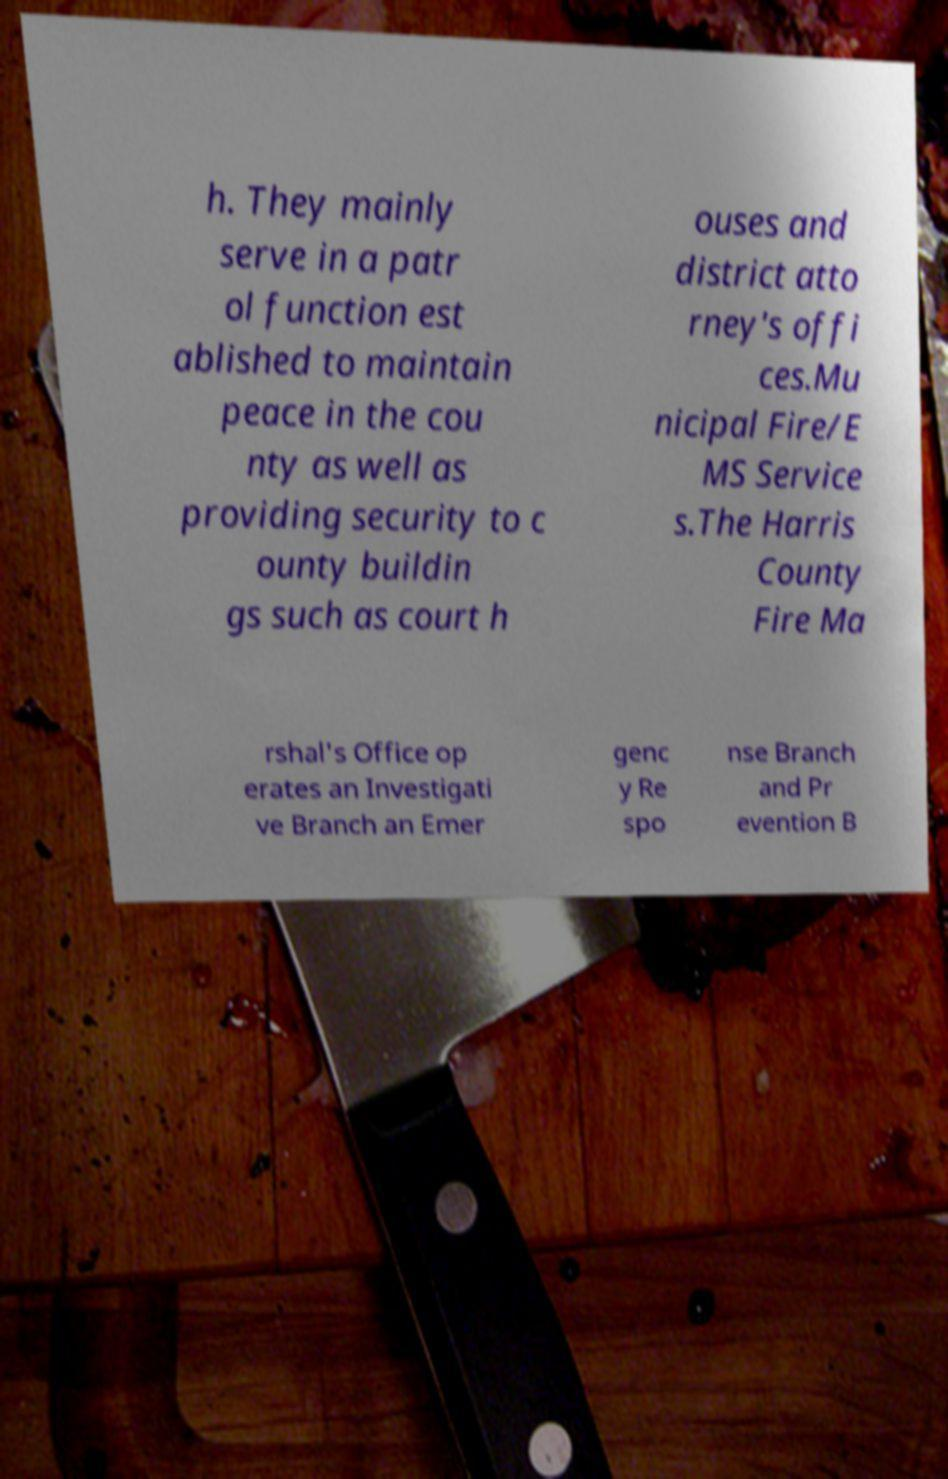I need the written content from this picture converted into text. Can you do that? h. They mainly serve in a patr ol function est ablished to maintain peace in the cou nty as well as providing security to c ounty buildin gs such as court h ouses and district atto rney's offi ces.Mu nicipal Fire/E MS Service s.The Harris County Fire Ma rshal's Office op erates an Investigati ve Branch an Emer genc y Re spo nse Branch and Pr evention B 